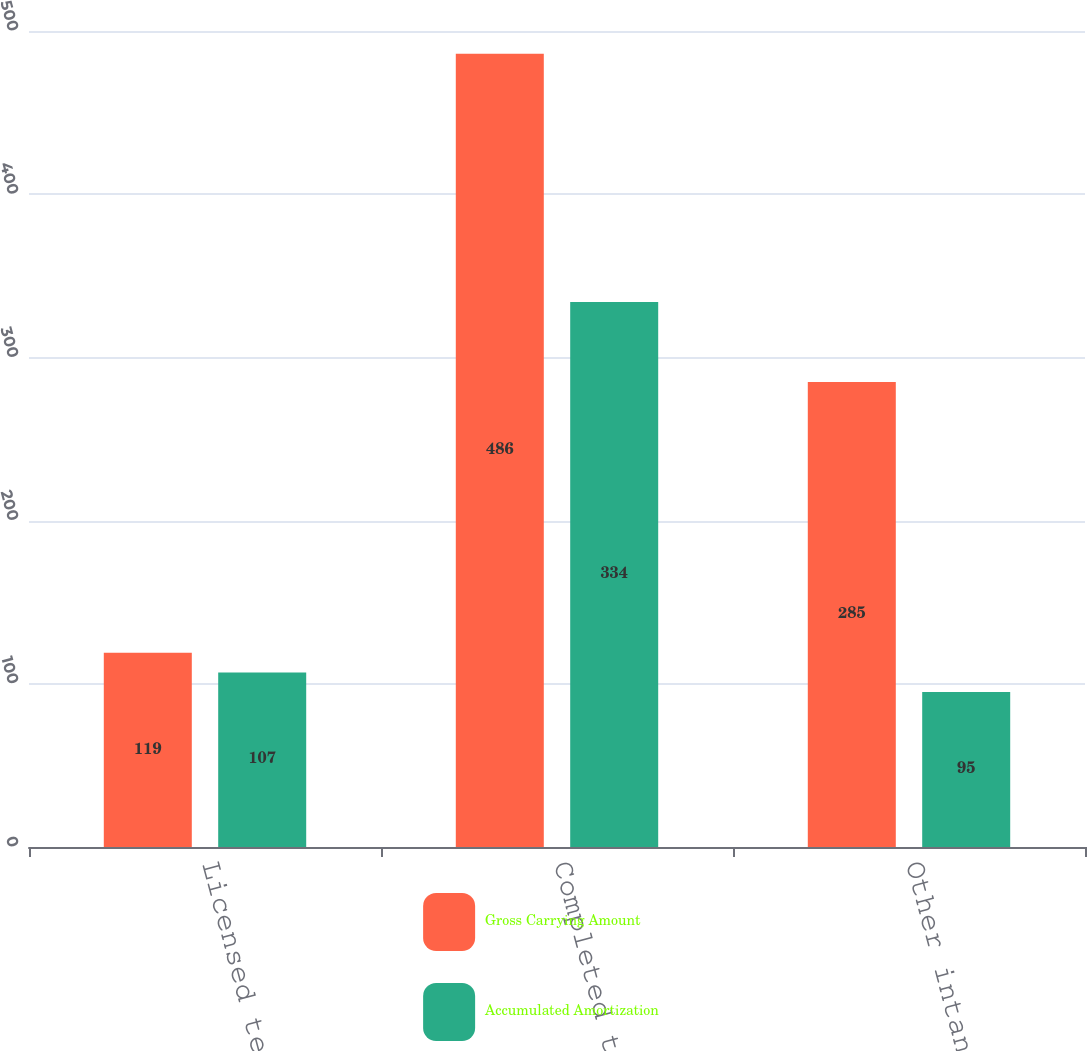Convert chart. <chart><loc_0><loc_0><loc_500><loc_500><stacked_bar_chart><ecel><fcel>Licensed technology<fcel>Completed technology<fcel>Other intangibles<nl><fcel>Gross Carrying Amount<fcel>119<fcel>486<fcel>285<nl><fcel>Accumulated Amortization<fcel>107<fcel>334<fcel>95<nl></chart> 